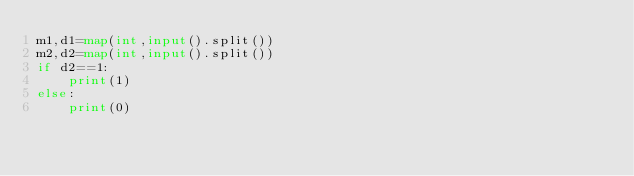Convert code to text. <code><loc_0><loc_0><loc_500><loc_500><_Python_>m1,d1=map(int,input().split())
m2,d2=map(int,input().split())
if d2==1:
    print(1)
else:
    print(0)</code> 